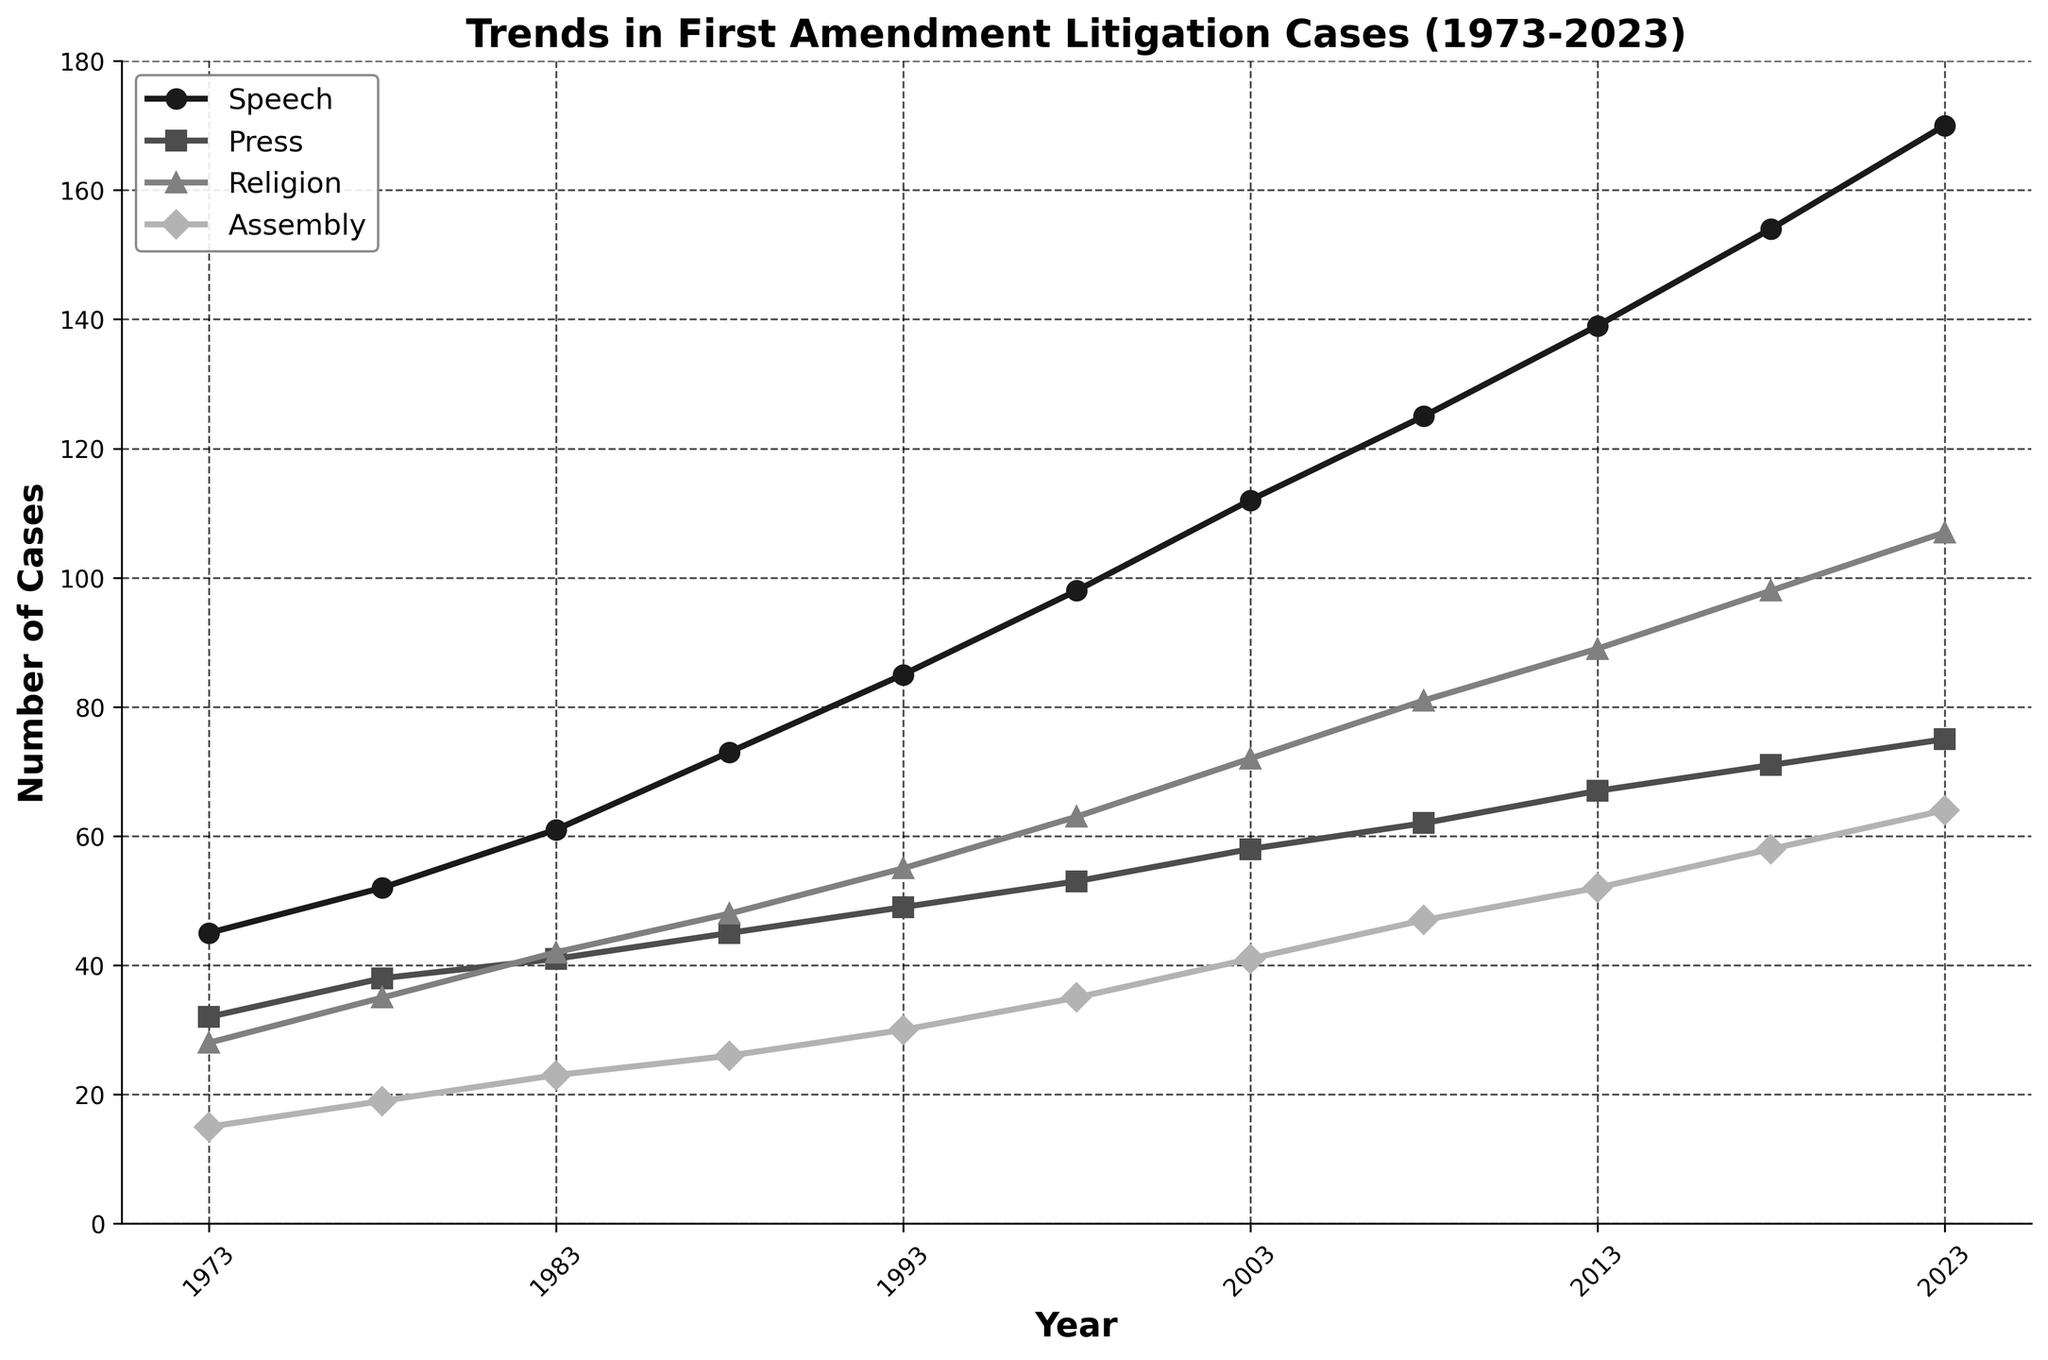Which type of First Amendment case had the highest number of litigations in 2023? Look at the end of the line chart at the year 2023 and identify which line reaches the highest value. The "Speech" category has the highest count.
Answer: Speech What is the difference in the number of speech cases between 1973 and 2023? Find the values for speech cases in 1973 and 2023 (45 and 170, respectively) and subtract the two numbers: 170 - 45 = 125.
Answer: 125 Which category showed the most consistent increase over the 50-year period? Observe the slopes of each line. The "Speech" category consistently increases without large fluctuations compared to other categories.
Answer: Speech Compare the number of assembly cases in 1983 and 2003. Which year had more cases? Look at the values for assembly cases in 1983 (23 cases) and 2003 (41 cases) and compare them: 41 is greater than 23, so 2003 had more cases.
Answer: 2003 Calculate the average number of religion cases between 1973 and 2023. Find the sum of religion cases over the years and divide by the number of data points. Sum of values is 728 (28+35+42+48+55+63+72+81+89+98+107), divided by 11 data points: 728/11 ≈ 66.18.
Answer: 66.18 How did the number of press cases change from 1993 to 1998? Compare the values of press cases in 1993 (49 cases) and 1998 (53 cases). The change is 53 - 49 = 4.
Answer: Increased by 4 Which year saw the biggest increase in the number of speech cases compared to the previous recorded year? Inspect the differences in speech cases between consecutive recorded years. The largest increase is between 1988 (73 cases) and 1993 (85 cases), with an increase of 12.
Answer: 1988 to 1993 What is the total sum of assembly cases from 1973 to 2023? Add up all the values for assembly cases from 1973 to 2023: 15 + 19 + 23 + 26 + 30 + 35 + 41 + 47 + 52 + 58 + 64 = 410.
Answer: 410 Among the four categories, which had the smallest number of cases in 2008? Look at the number of cases for each category in 2008: Speech (125), Press (62), Religion (81), Assembly (47). The "Assembly" category had the smallest number of cases.
Answer: Assembly Compare the sum of press and religion cases in 1978 to the sum of these cases in 2023. Calculate the sums separately: (38 + 35) for 1978, which equals 73, and (75 + 107) for 2023, which equals 182.
Answer: 182 